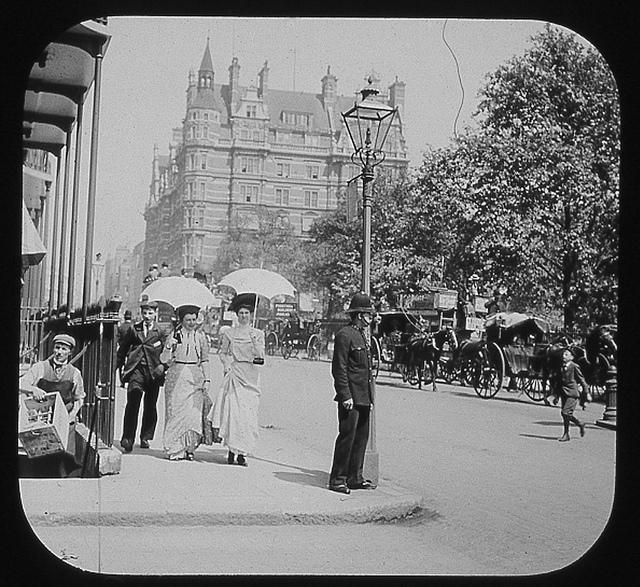How many girls do you see that is wearing a hat?
Give a very brief answer. 2. How many people are visible?
Give a very brief answer. 5. 